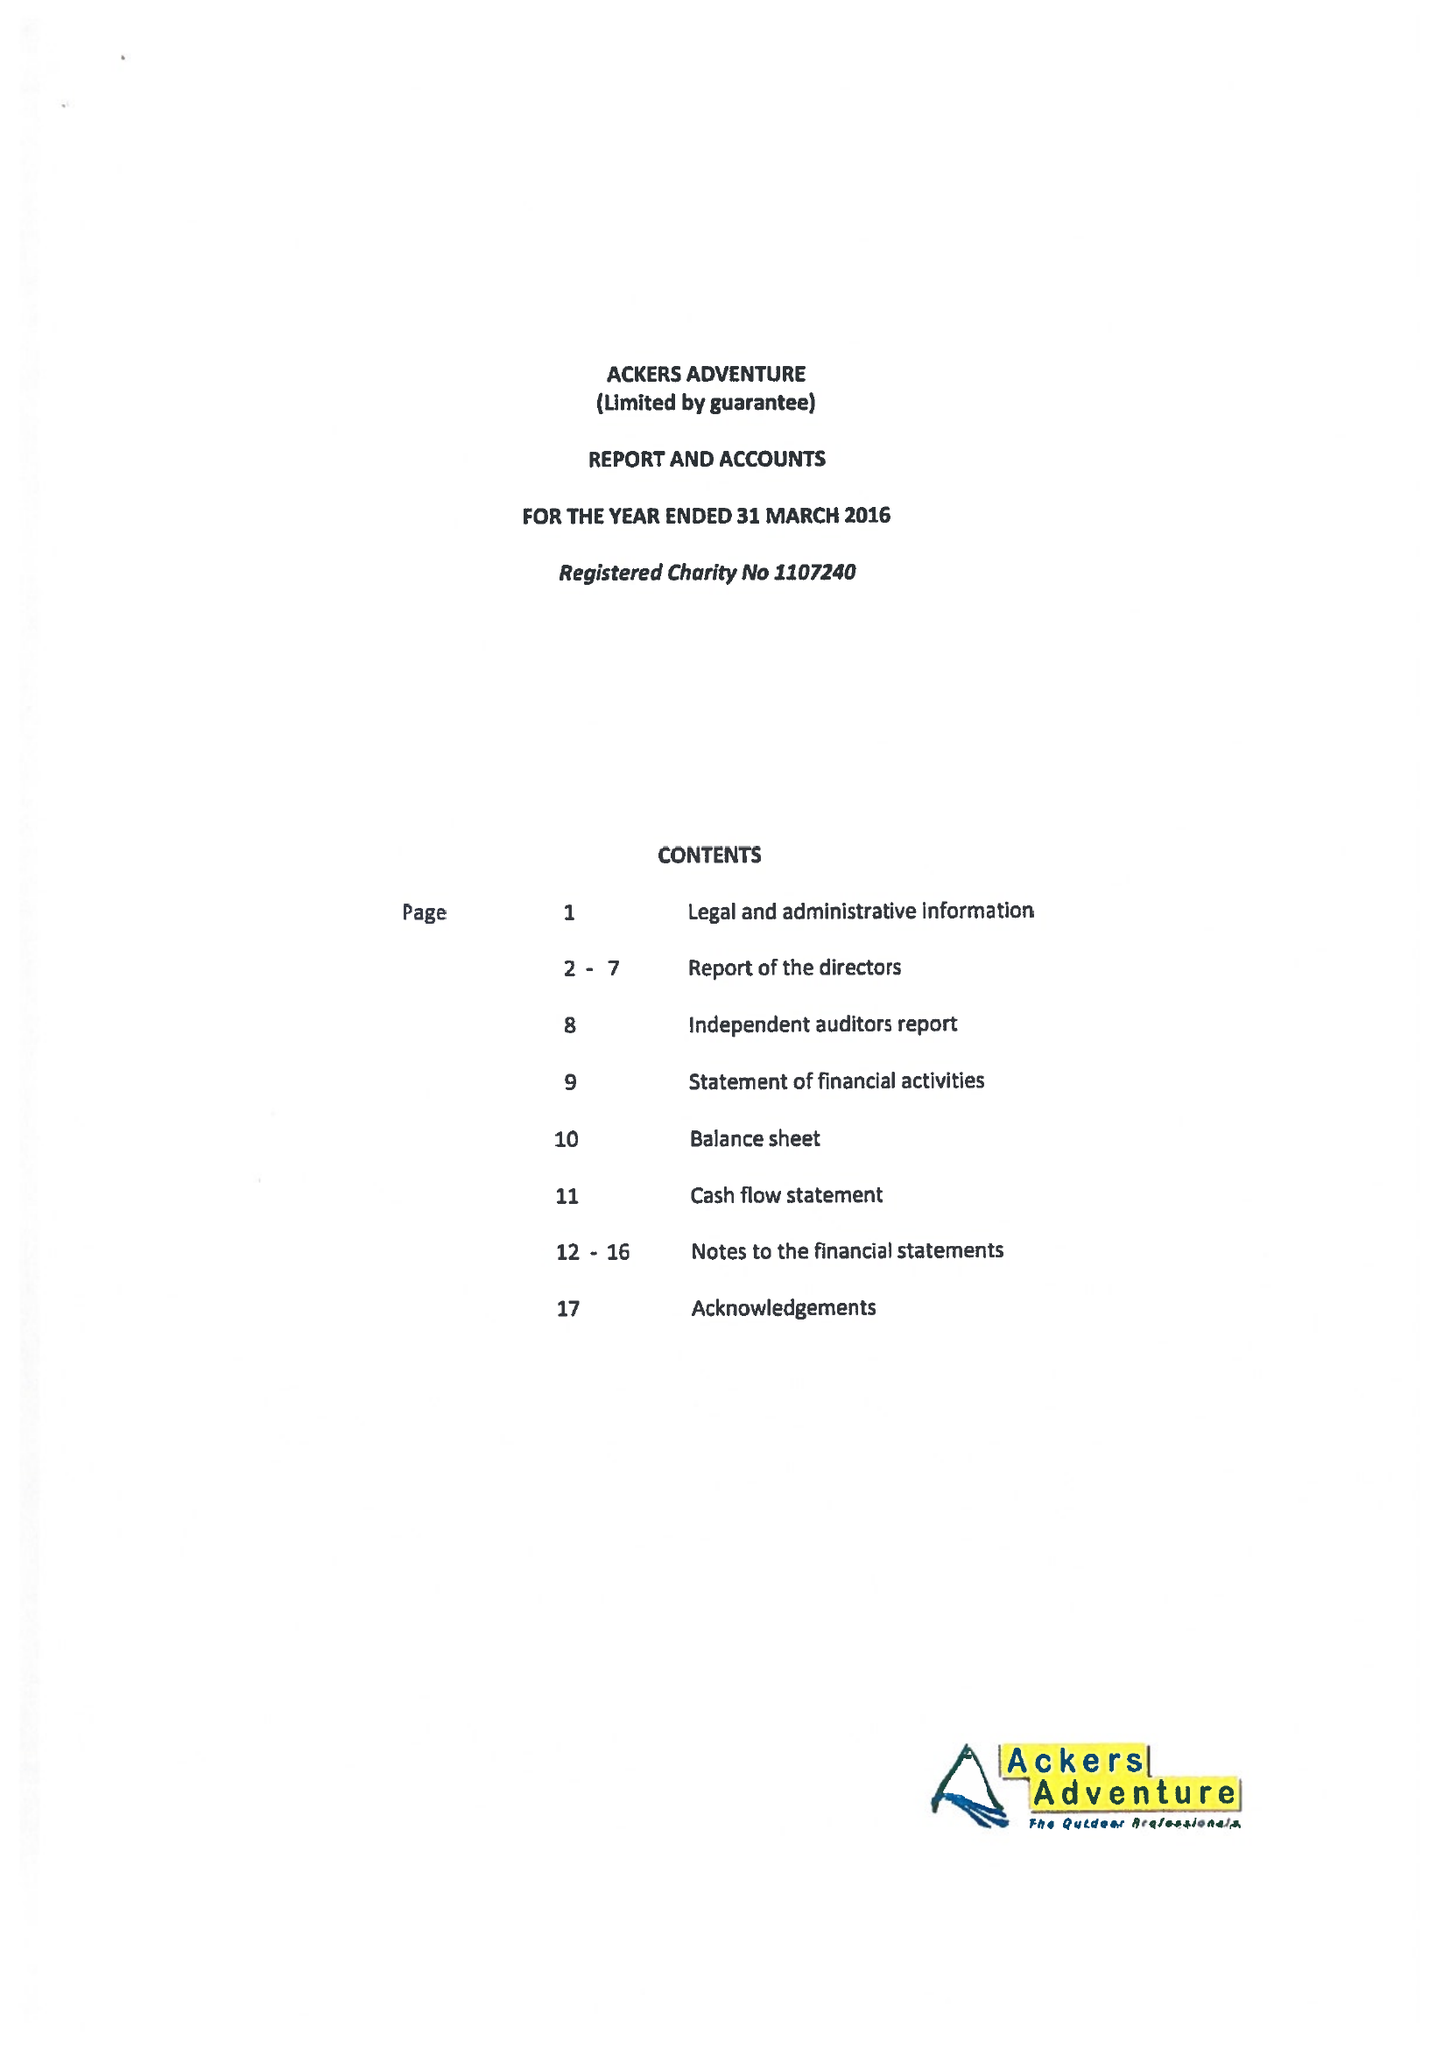What is the value for the address__street_line?
Answer the question using a single word or phrase. GOLDEN HILLOCK ROAD 